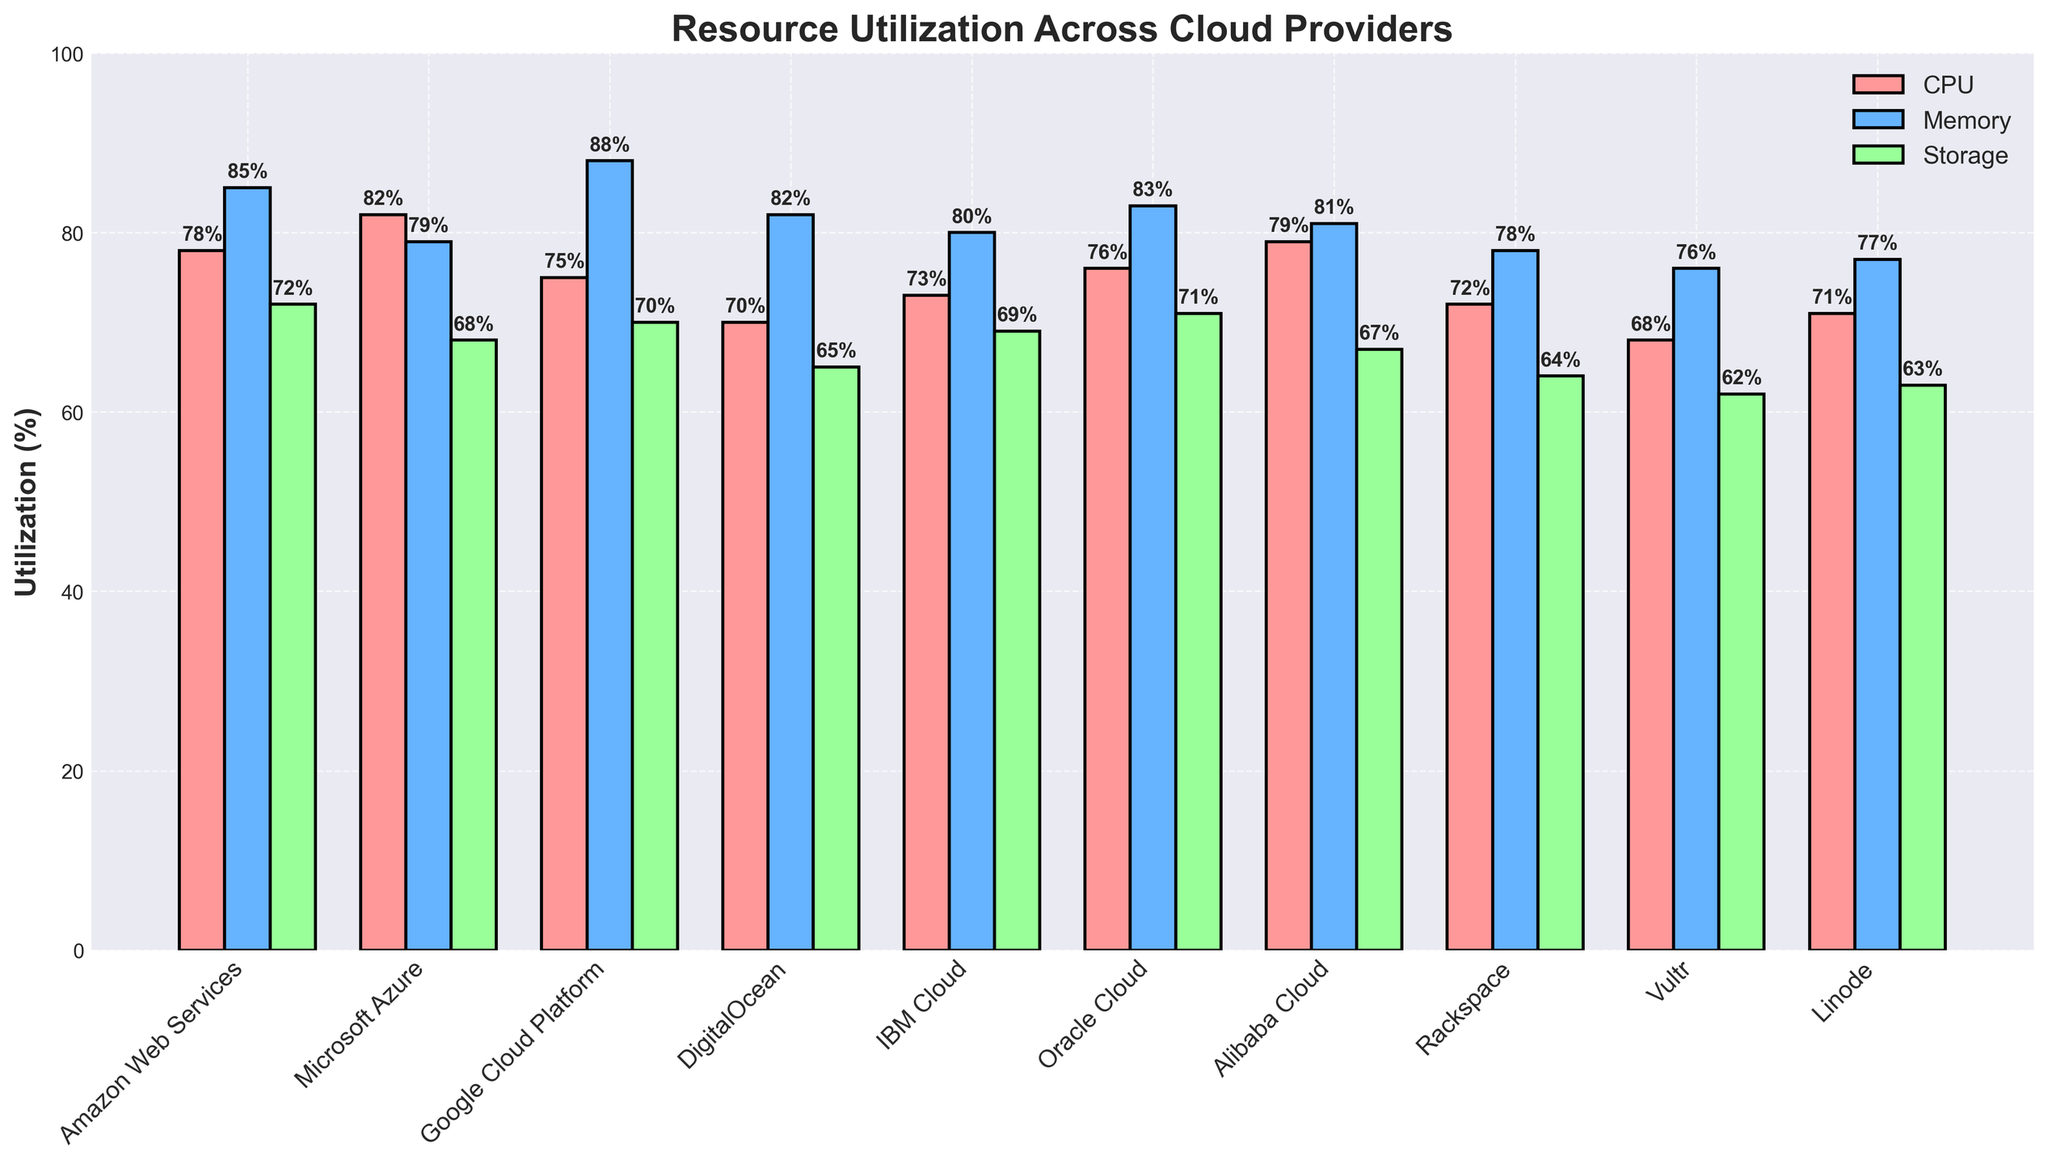What is the highest CPU utilization percentage among the cloud providers? Identify the cloud provider bar with the highest value in the 'CPU Utilization (%)' category. The highest bar corresponds to Microsoft Azure at 82%.
Answer: 82% Which cloud provider has the lowest storage utilization percentage? Find the cloud provider bar with the shortest height in the 'Storage Utilization (%)' category. The shortest bar is for Vultr, which has a storage utilization of 62%.
Answer: Vultr How does IBM Cloud's memory utilization compare to Amazon Web Services? Look at the heights of the bars for memory utilization of IBM Cloud and Amazon Web Services. IBM Cloud has a memory utilization of 80%, while Amazon Web Services has 85%, making Amazon Web Services higher.
Answer: Amazon Web Services is higher Which cloud provider has a higher average utilization across all resources: DigitalOcean or Rackspace? Calculate the average utilization for both providers across CPU, memory, and storage. 
DigitalOcean: (70 + 82 + 65) / 3 = 72.33%
Rackspace: (72 + 78 + 64) / 3 = 71.33%
DigitalOcean has a higher average utilization.
Answer: DigitalOcean What is the difference in storage utilization between Google Cloud Platform and Oracle Cloud? Subtract the storage utilization of Google Cloud Platform (70%) from Oracle Cloud (71%). 
71% - 70% = 1%
Answer: 1% What is the average CPU utilization across all cloud providers? Sum all CPU Utilization percentages and divide by the number of providers (10). 
(78 + 82 + 75 + 70 + 73 + 76 + 79 + 72 + 68 + 71) / 10 = 74.4%
Answer: 74.4% Which cloud provider has the closest memory utilization to Alibaba Cloud? Find the memory utilization value for Alibaba Cloud (81%) and compare it with others to find the closest. Microsoft Azure has a memory utilization of 79%, which is the closest.
Answer: Microsoft Azure Is there any cloud provider that has equal utilization percentages for any two resources? Compare the utilization percentages for CPU, memory, and storage for each provider to identify if any two values are equal. None of the providers have equal utilization percentages for any two resources.
Answer: No What is the utilization range of CPU utilization across all cloud providers? Identify the highest and lowest CPU utilization percentages to find the range. The highest CPU utilization is 82% (Microsoft Azure) and the lowest is 68% (Vultr). The range is 82% - 68% = 14%.
Answer: 14% Which cloud provider shows a wide disparity between memory and storage utilization percentages? Look for large differences between memory and storage utilization for each provider. Google Cloud Platform has a memory utilization of 88% and storage utilization of 70%, giving a difference of 18%, the widest disparity among the providers.
Answer: Google Cloud Platform 